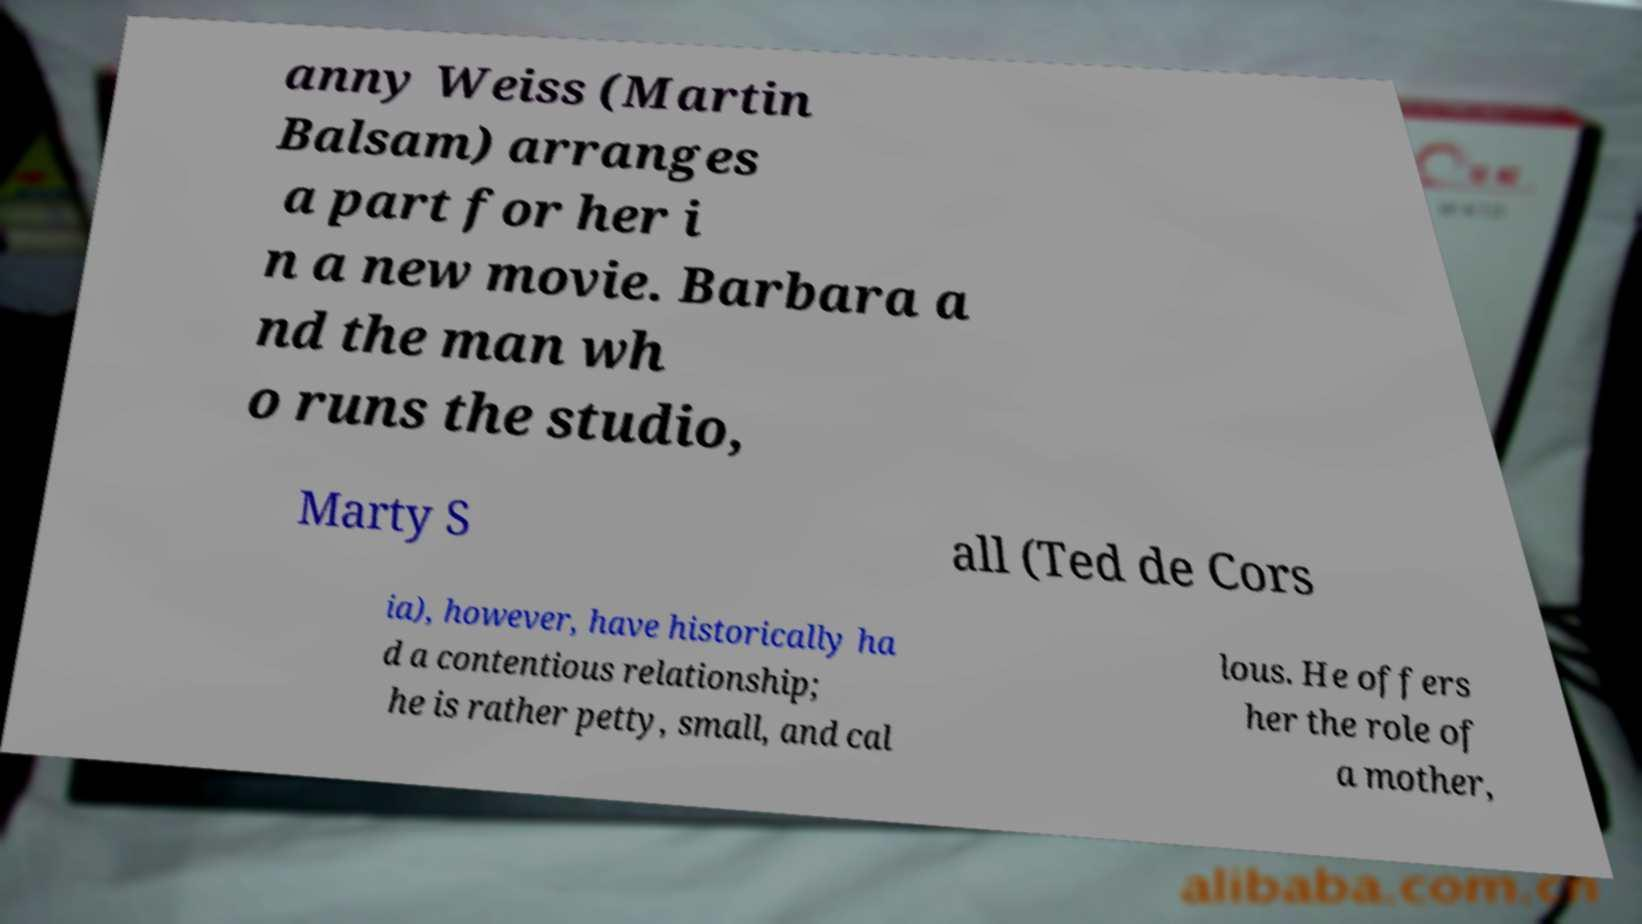There's text embedded in this image that I need extracted. Can you transcribe it verbatim? anny Weiss (Martin Balsam) arranges a part for her i n a new movie. Barbara a nd the man wh o runs the studio, Marty S all (Ted de Cors ia), however, have historically ha d a contentious relationship; he is rather petty, small, and cal lous. He offers her the role of a mother, 